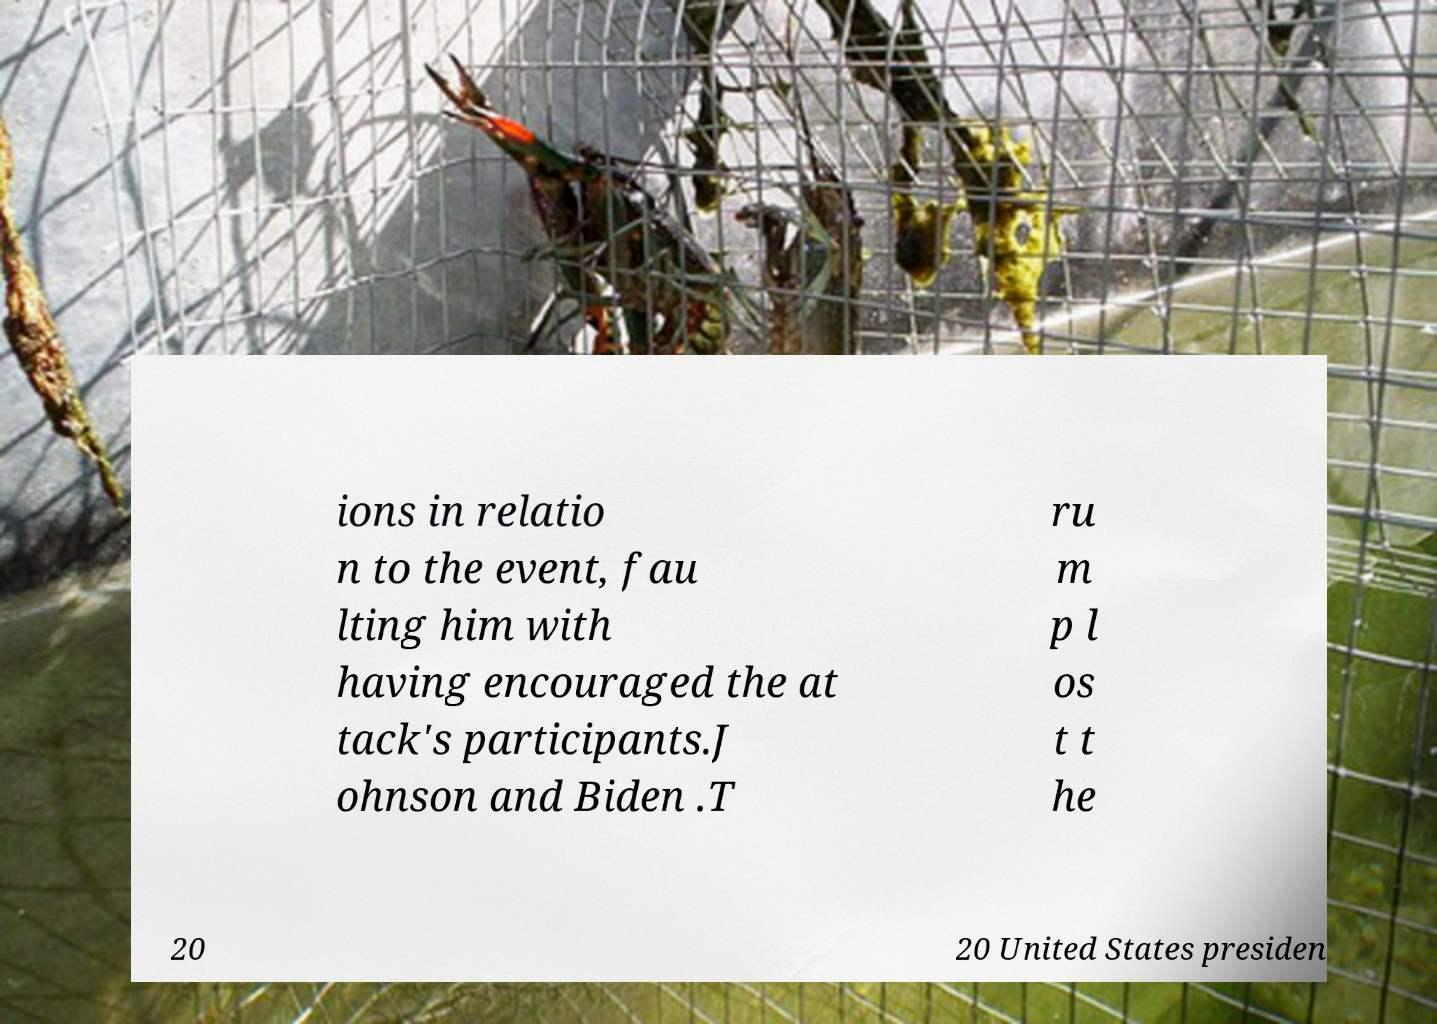There's text embedded in this image that I need extracted. Can you transcribe it verbatim? ions in relatio n to the event, fau lting him with having encouraged the at tack's participants.J ohnson and Biden .T ru m p l os t t he 20 20 United States presiden 